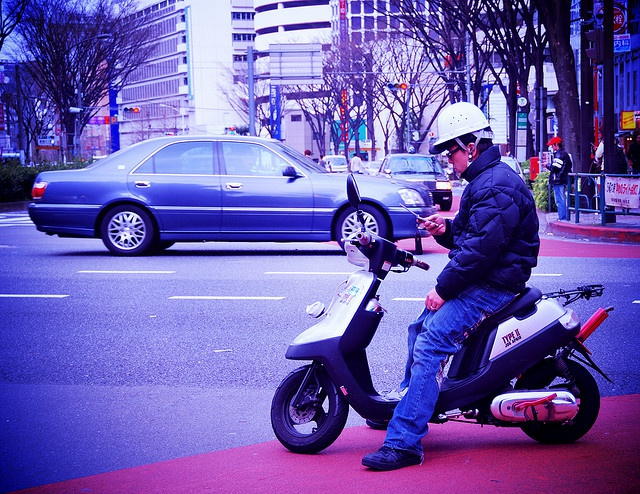Describe the objects in this image and their specific colors. I can see motorcycle in black, navy, lavender, and violet tones, car in black, lightblue, darkblue, lavender, and blue tones, people in black, navy, darkblue, and blue tones, car in black, lightblue, and lavender tones, and people in black, navy, blue, and darkblue tones in this image. 